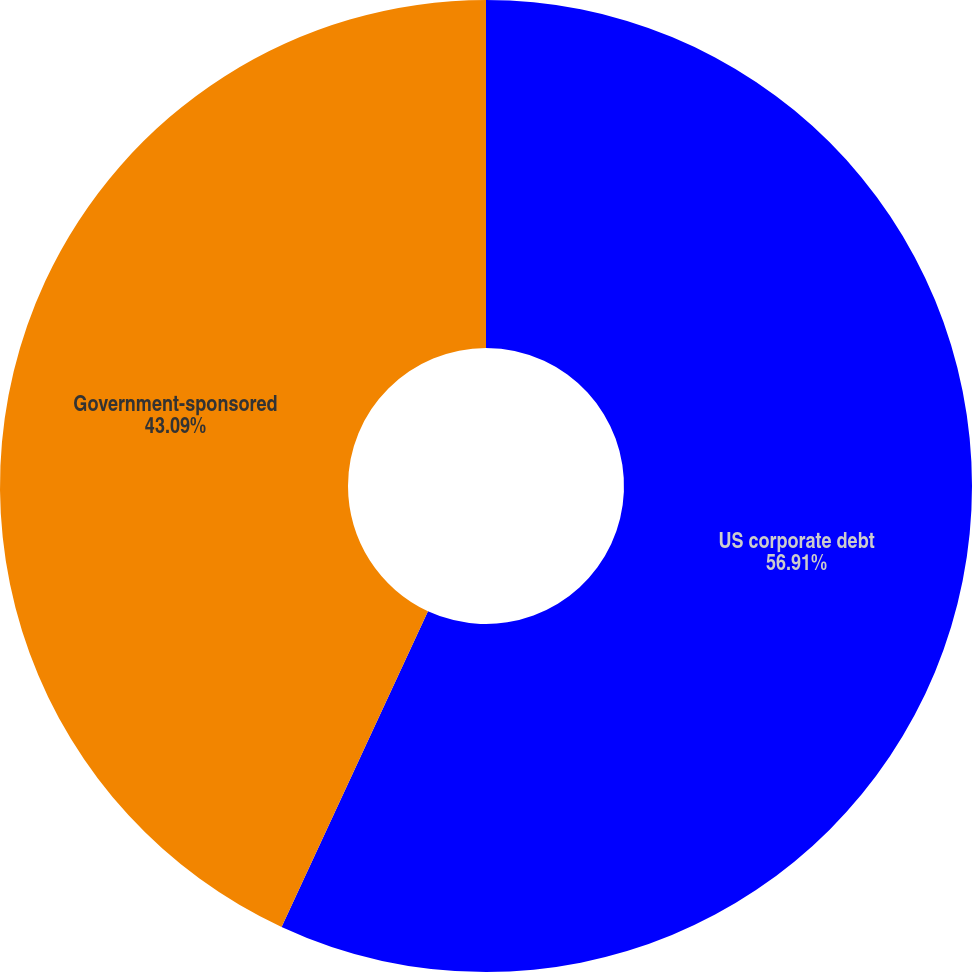<chart> <loc_0><loc_0><loc_500><loc_500><pie_chart><fcel>US corporate debt<fcel>Government-sponsored<nl><fcel>56.91%<fcel>43.09%<nl></chart> 